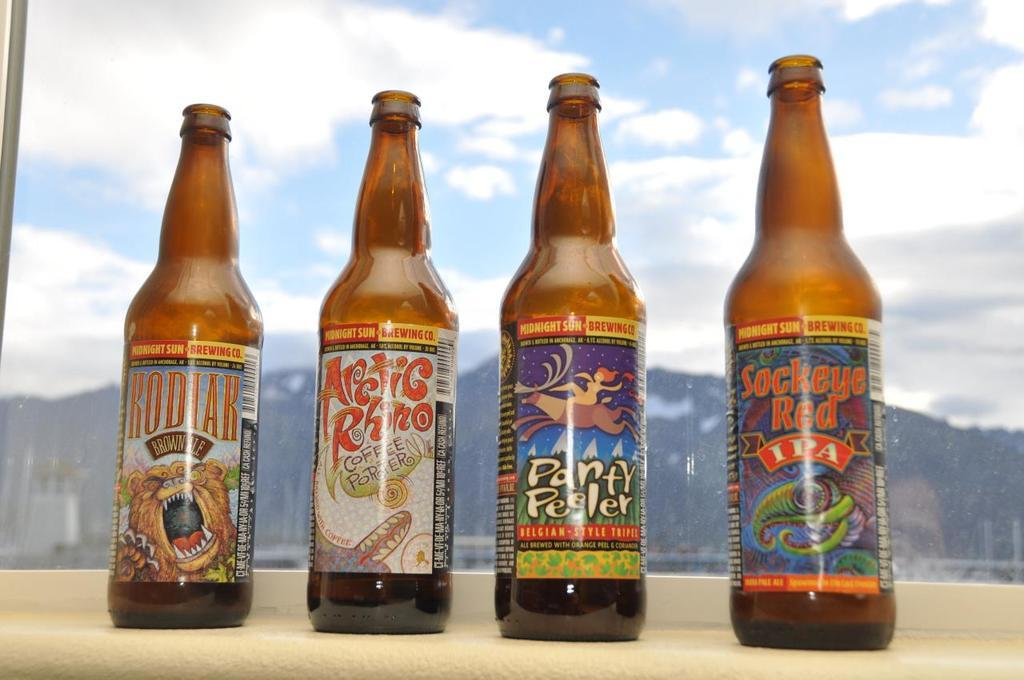<image>
Relay a brief, clear account of the picture shown. Four bottles of beer are lined up with Sockeye Red on the far right side. 